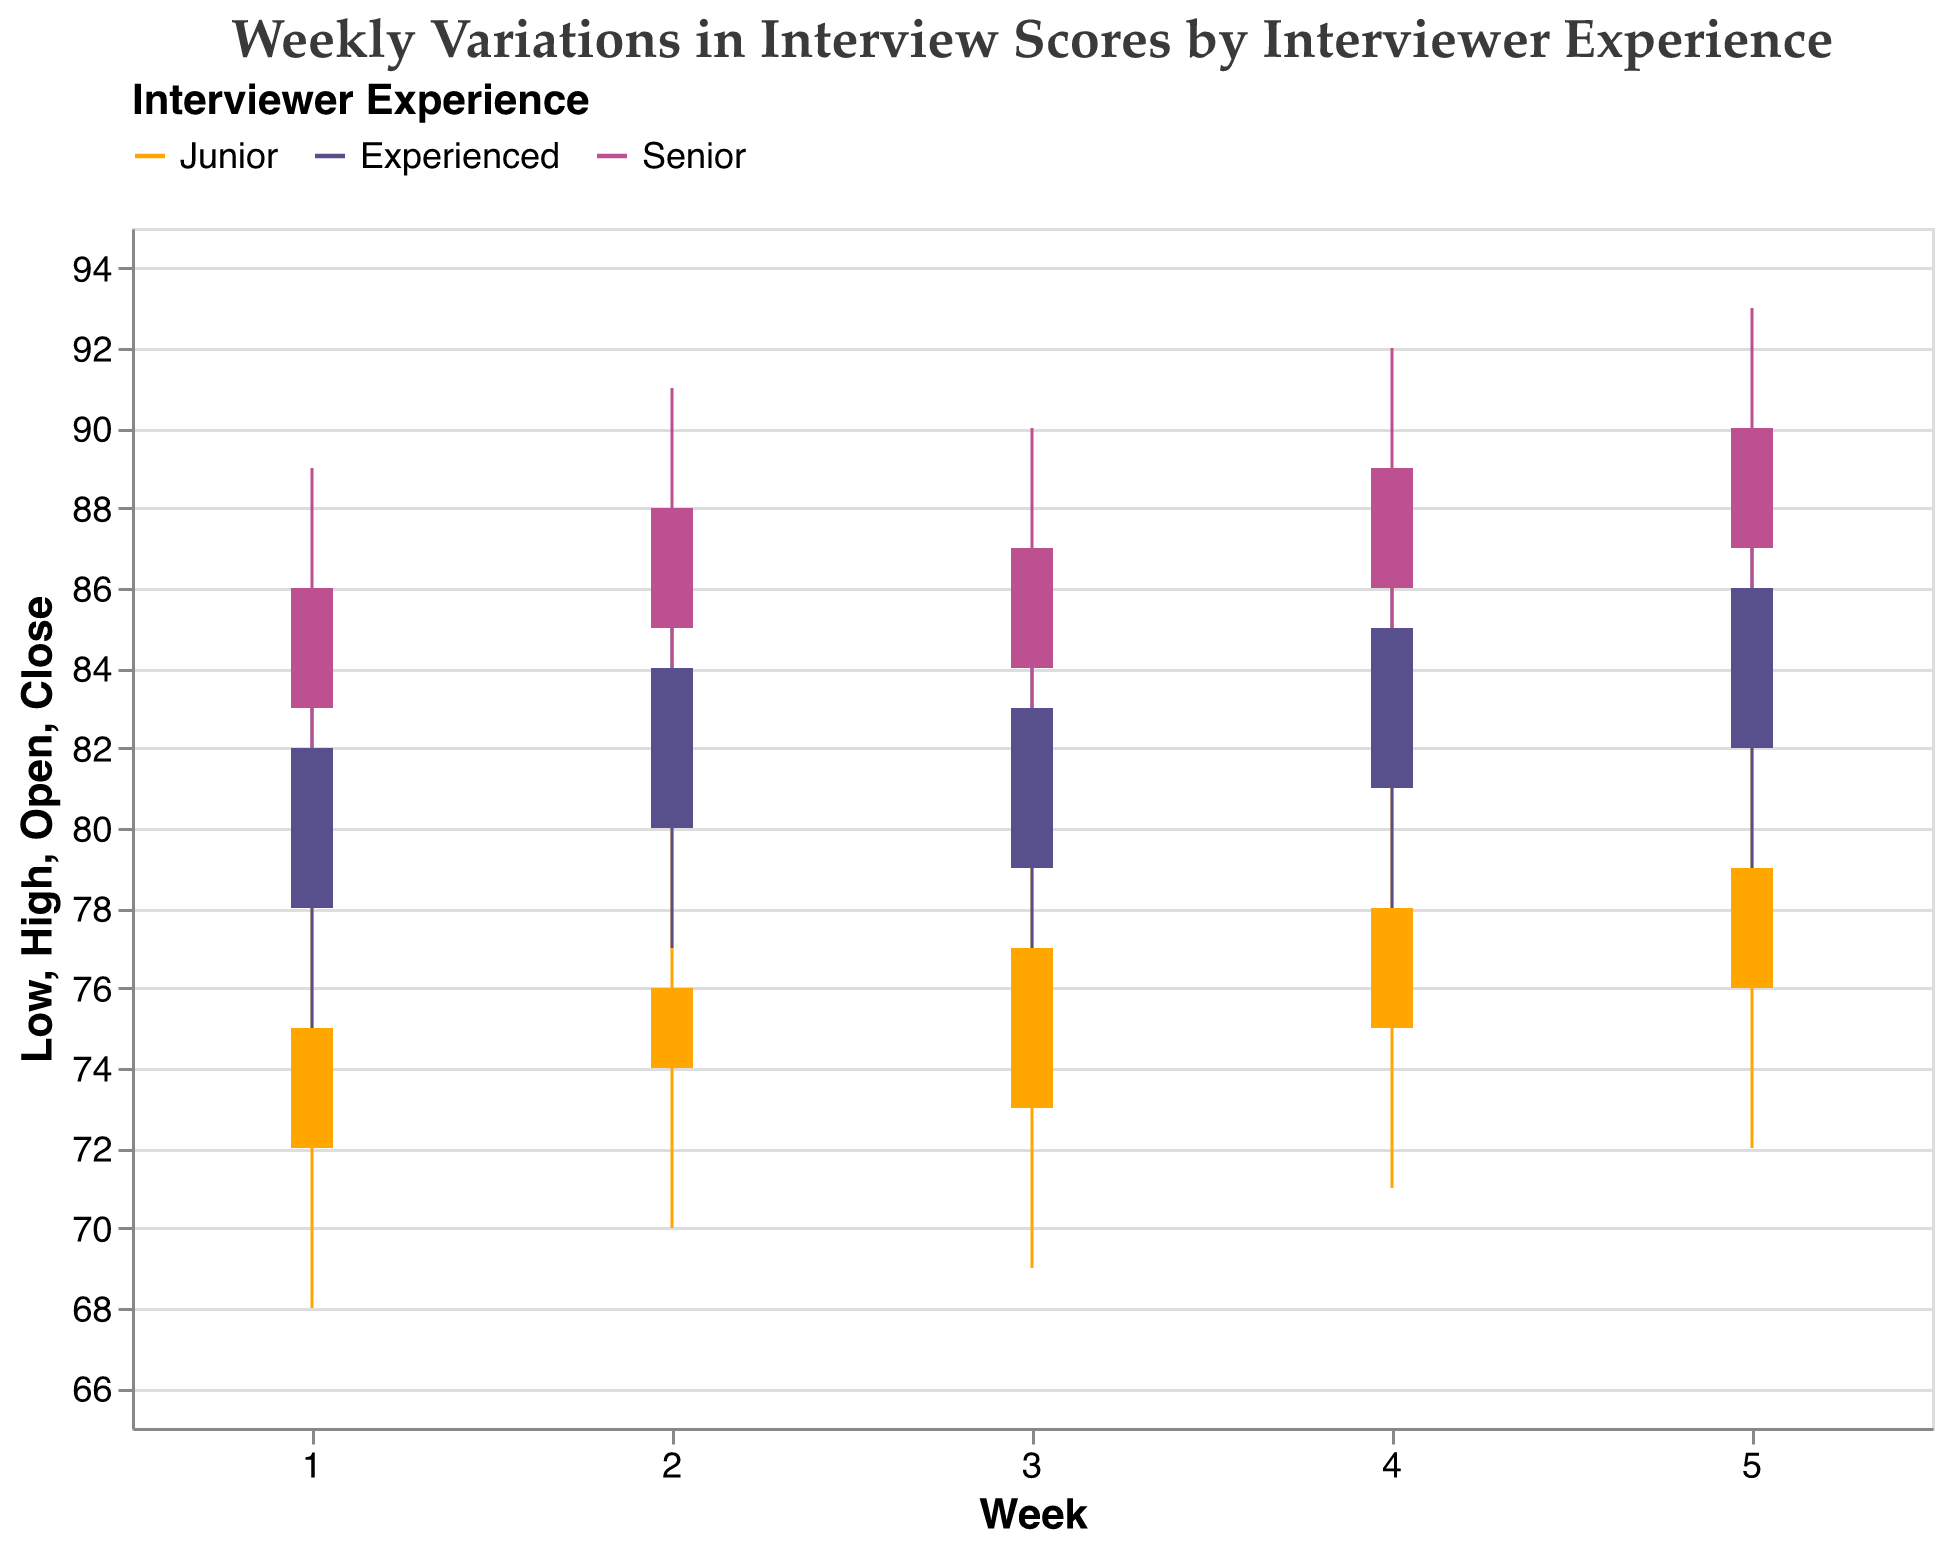What is the highest score achieved by a senior interviewer in Week 3? To find the highest score achieved by a senior interviewer in Week 3, refer to the 'High' column for Week 3 under 'Senior'. The value is 90.
Answer: 90 What is the average closing score for junior interviewers over the 5 weeks? To find the average closing score, sum the weekly closing scores for junior interviewers (75, 76, 77, 78, 79) which equals 385. Then, divide by the number of weeks (5), giving 385/5 = 77.
Answer: 77 In which week do experienced interviewers show the smallest range in interview scores from Low to High? To find this, calculate the difference between High and Low for experienced interviewers in each week. The differences are (85-75)=10, (87-77)=10, (86-76)=10, (88-78)=10, (89-79)=10. The differences are the same for all weeks, so there is no single week with the smallest range.
Answer: No single week By how much did the closing score for senior interviewers change from Week 2 to Week 3? For Week 2, the closing score is 88, and for Week 3, it is 87. The change is calculated as 88 - 87 = 1.
Answer: 1 What is the opening score for junior interviewers in Week 4? Refer to the 'Open' column for junior interviewers in Week 4. The value is 75.
Answer: 75 Which group of interviewers has the consistently highest closing scores over the weeks? Compare the closing scores for each week across the three interview groups. Senior interviewers have the highest closing scores each week: 86, 88, 87, 89, 90.
Answer: Senior Among all weeks and groups, identify the week and group with the lowest closing score. Review all 'Close' scores across weeks and groups. The lowest closing score is for junior interviewers in Week 1, which is 75.
Answer: Week 1, Junior How does the variability in scores (range between High and Low) for junior interviewers compare between Week 1 and Week 5? For Week 1, the range is 79 - 68 = 11. For Week 5, the range is 83 - 72 = 11. The variability in scores is the same (11) in both weeks.
Answer: Same What’s the difference between the high scores of experienced interviewers in Week 4 and Week 5? The high score for experienced interviewers in Week 4 is 88, and in Week 5 it is 89. The difference is 89 - 88 = 1.
Answer: 1 